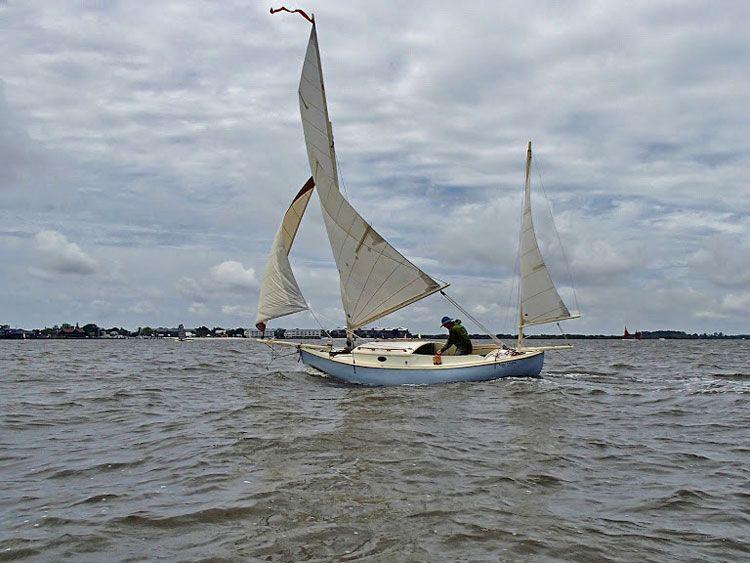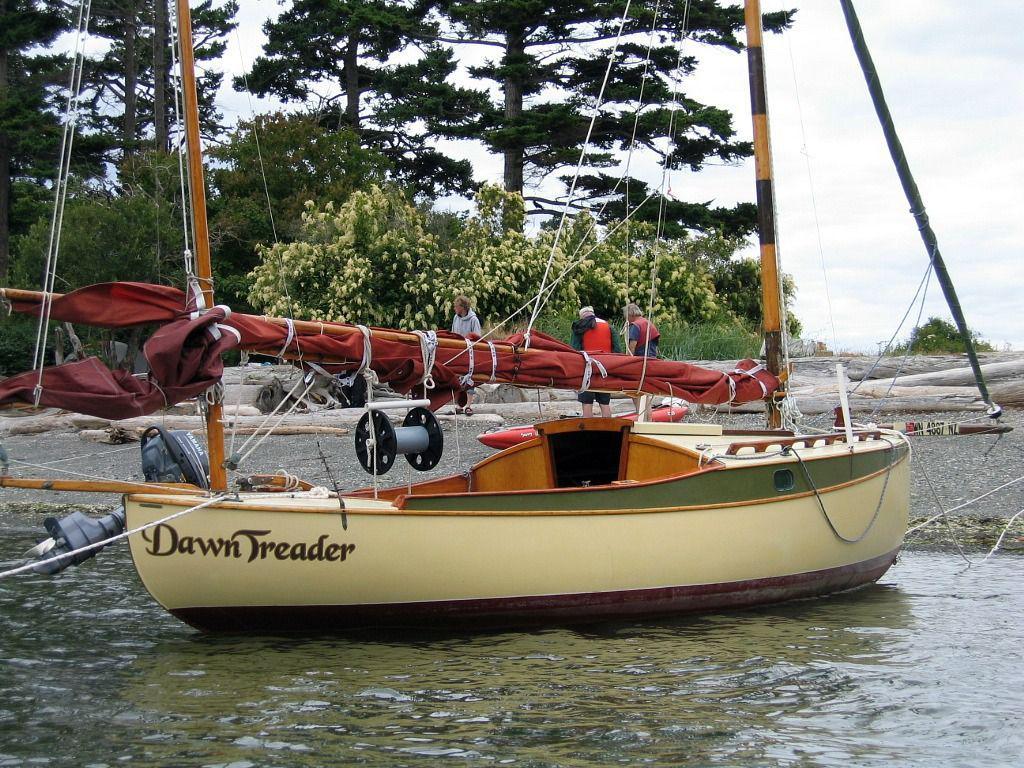The first image is the image on the left, the second image is the image on the right. Examine the images to the left and right. Is the description "The left and right image contains the same number of sailboats with open sails." accurate? Answer yes or no. No. The first image is the image on the left, the second image is the image on the right. For the images displayed, is the sentence "There are no more than three sails." factually correct? Answer yes or no. Yes. 